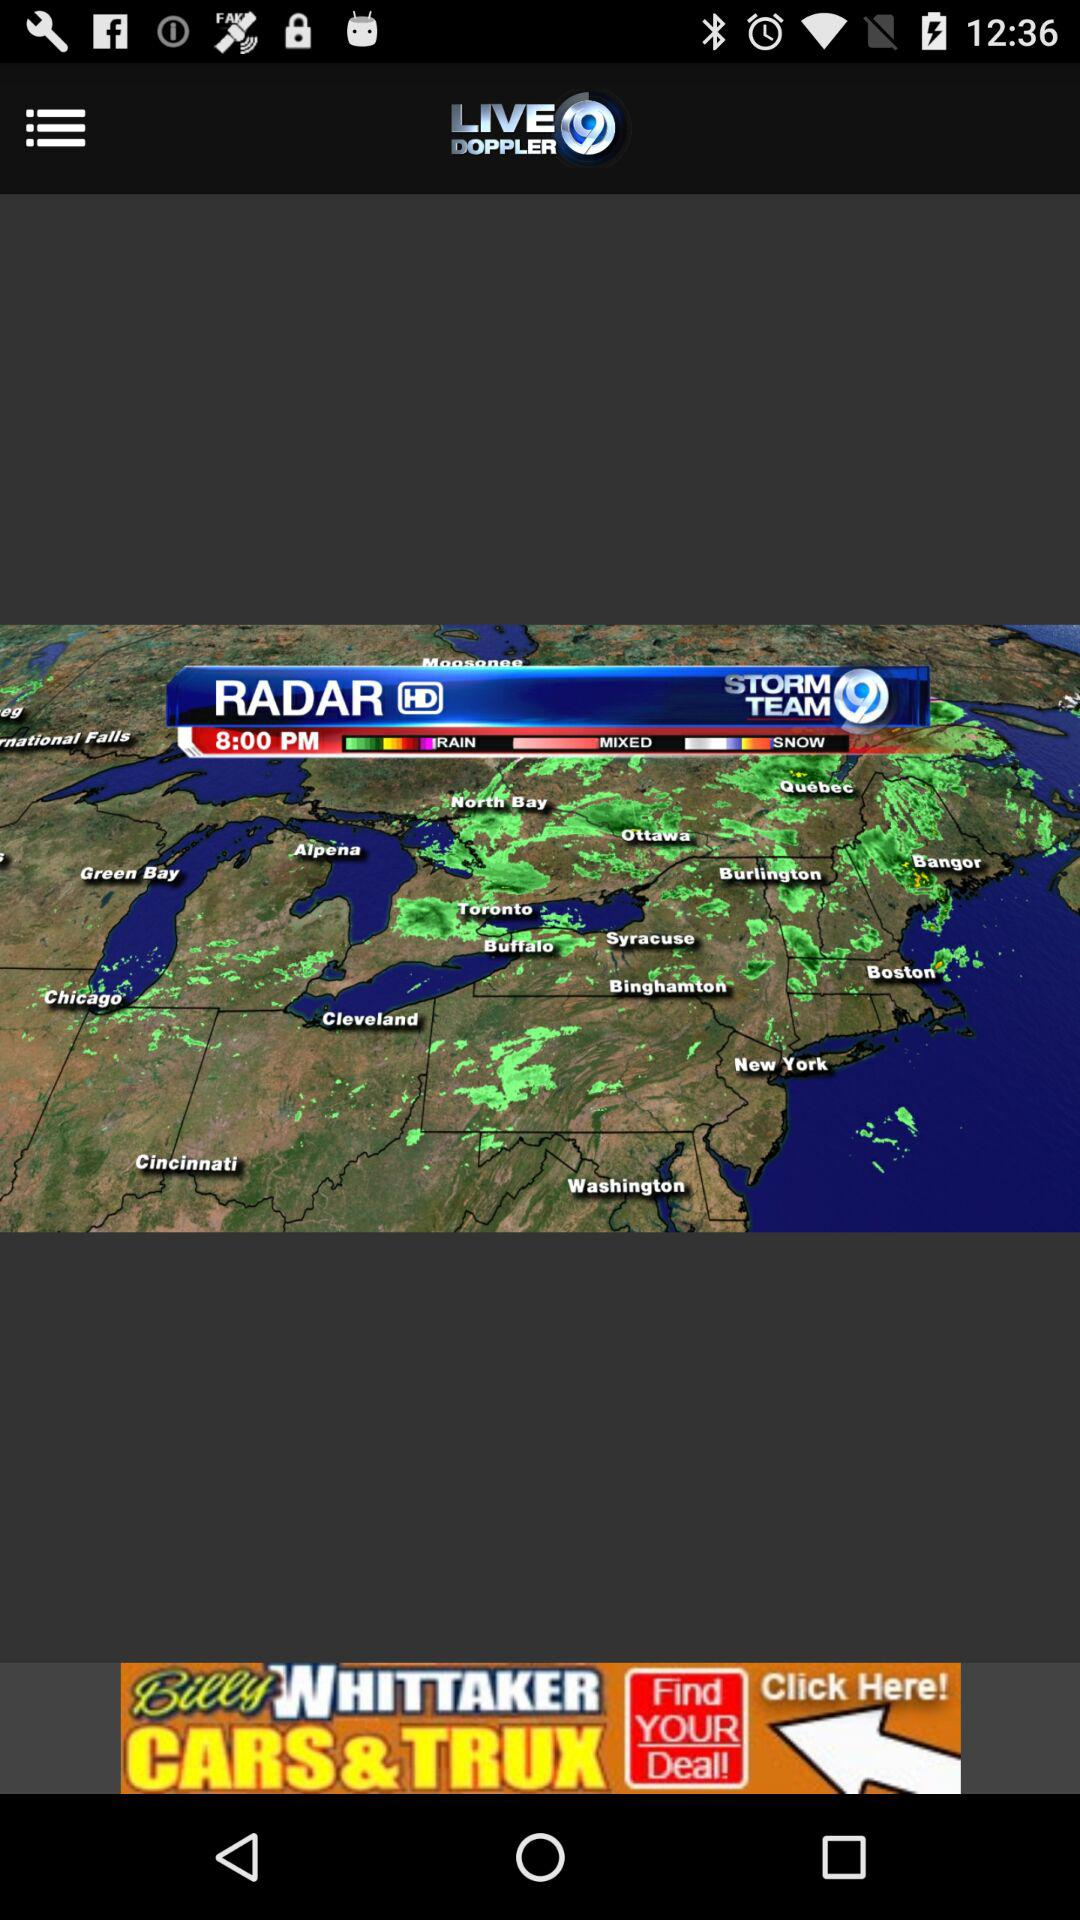What is the application Name? The application name is "LIVE DOPPLER". 